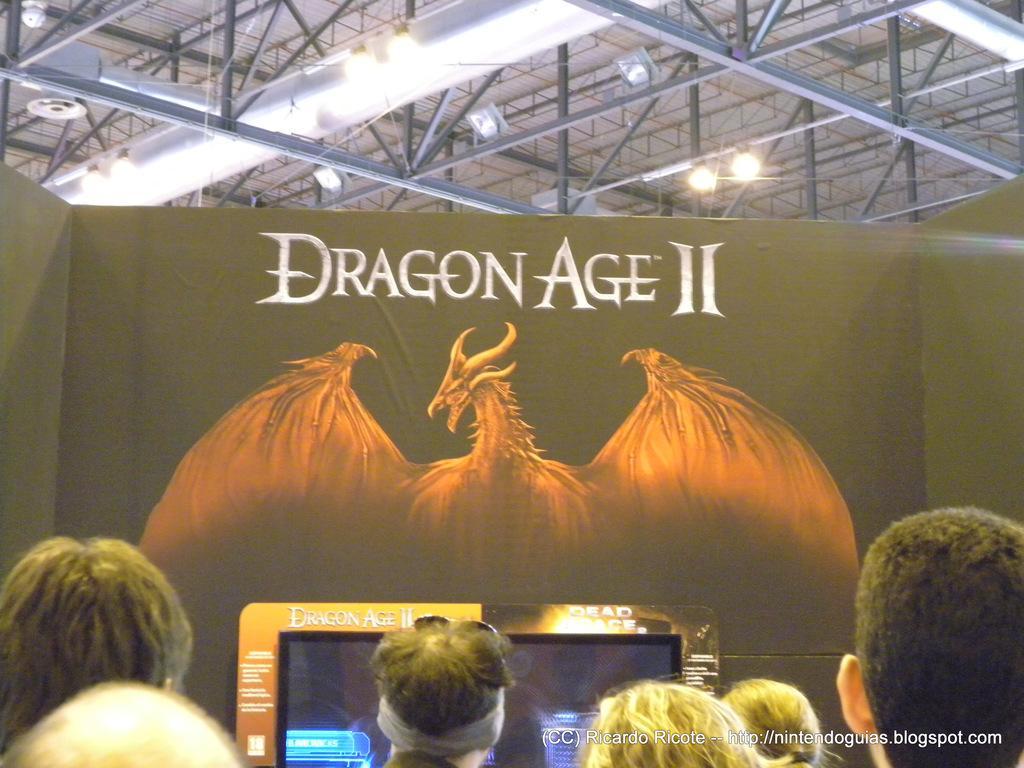Could you give a brief overview of what you see in this image? In this picture we can see a group of people, screen, poster and in the background we can see rods, lights. 